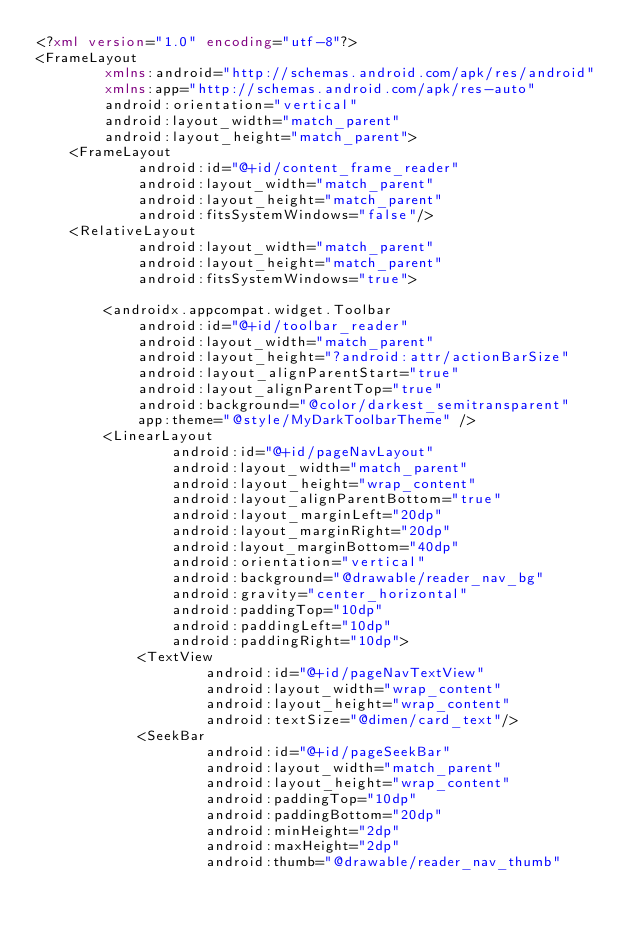Convert code to text. <code><loc_0><loc_0><loc_500><loc_500><_XML_><?xml version="1.0" encoding="utf-8"?>
<FrameLayout
        xmlns:android="http://schemas.android.com/apk/res/android"
        xmlns:app="http://schemas.android.com/apk/res-auto"
        android:orientation="vertical"
        android:layout_width="match_parent"
        android:layout_height="match_parent">
    <FrameLayout
            android:id="@+id/content_frame_reader"
            android:layout_width="match_parent"
            android:layout_height="match_parent"
            android:fitsSystemWindows="false"/>
    <RelativeLayout
            android:layout_width="match_parent"
            android:layout_height="match_parent"
            android:fitsSystemWindows="true">

        <androidx.appcompat.widget.Toolbar
            android:id="@+id/toolbar_reader"
            android:layout_width="match_parent"
            android:layout_height="?android:attr/actionBarSize"
            android:layout_alignParentStart="true"
            android:layout_alignParentTop="true"
            android:background="@color/darkest_semitransparent"
            app:theme="@style/MyDarkToolbarTheme" />
        <LinearLayout
                android:id="@+id/pageNavLayout"
                android:layout_width="match_parent"
                android:layout_height="wrap_content"
                android:layout_alignParentBottom="true"
                android:layout_marginLeft="20dp"
                android:layout_marginRight="20dp"
                android:layout_marginBottom="40dp"
                android:orientation="vertical"
                android:background="@drawable/reader_nav_bg"
                android:gravity="center_horizontal"
                android:paddingTop="10dp"
                android:paddingLeft="10dp"
                android:paddingRight="10dp">
            <TextView
                    android:id="@+id/pageNavTextView"
                    android:layout_width="wrap_content"
                    android:layout_height="wrap_content"
                    android:textSize="@dimen/card_text"/>
            <SeekBar
                    android:id="@+id/pageSeekBar"
                    android:layout_width="match_parent"
                    android:layout_height="wrap_content"
                    android:paddingTop="10dp"
                    android:paddingBottom="20dp"
                    android:minHeight="2dp"
                    android:maxHeight="2dp"
                    android:thumb="@drawable/reader_nav_thumb"</code> 